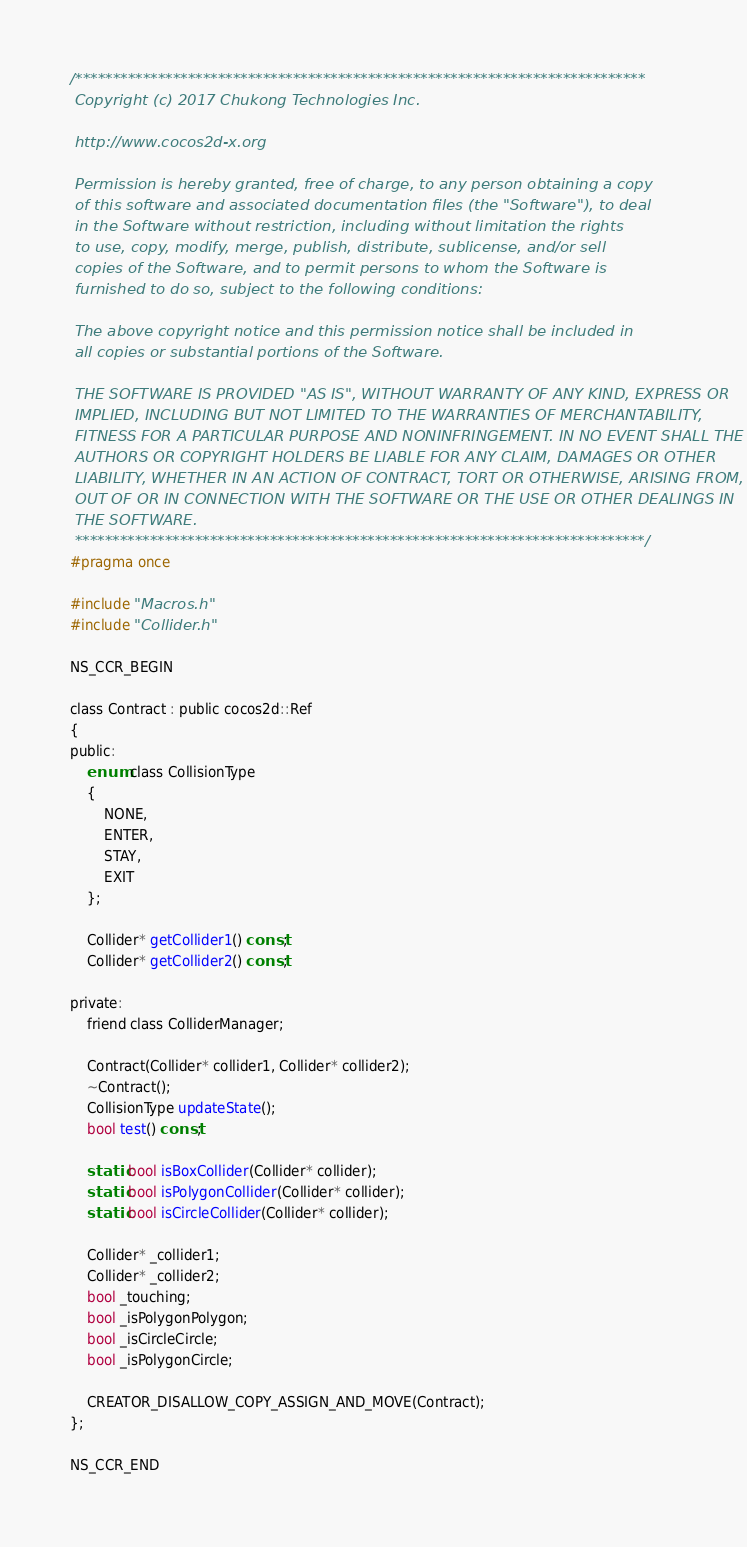<code> <loc_0><loc_0><loc_500><loc_500><_C_>/****************************************************************************
 Copyright (c) 2017 Chukong Technologies Inc.
 
 http://www.cocos2d-x.org
 
 Permission is hereby granted, free of charge, to any person obtaining a copy
 of this software and associated documentation files (the "Software"), to deal
 in the Software without restriction, including without limitation the rights
 to use, copy, modify, merge, publish, distribute, sublicense, and/or sell
 copies of the Software, and to permit persons to whom the Software is
 furnished to do so, subject to the following conditions:
 
 The above copyright notice and this permission notice shall be included in
 all copies or substantial portions of the Software.
 
 THE SOFTWARE IS PROVIDED "AS IS", WITHOUT WARRANTY OF ANY KIND, EXPRESS OR
 IMPLIED, INCLUDING BUT NOT LIMITED TO THE WARRANTIES OF MERCHANTABILITY,
 FITNESS FOR A PARTICULAR PURPOSE AND NONINFRINGEMENT. IN NO EVENT SHALL THE
 AUTHORS OR COPYRIGHT HOLDERS BE LIABLE FOR ANY CLAIM, DAMAGES OR OTHER
 LIABILITY, WHETHER IN AN ACTION OF CONTRACT, TORT OR OTHERWISE, ARISING FROM,
 OUT OF OR IN CONNECTION WITH THE SOFTWARE OR THE USE OR OTHER DEALINGS IN
 THE SOFTWARE.
 ****************************************************************************/
#pragma once

#include "Macros.h"
#include "Collider.h"

NS_CCR_BEGIN

class Contract : public cocos2d::Ref
{
public:
    enum class CollisionType
    {
        NONE,
        ENTER,
        STAY,
        EXIT
    };
    
    Collider* getCollider1() const;
    Collider* getCollider2() const;
    
private:
    friend class ColliderManager;
    
    Contract(Collider* collider1, Collider* collider2);
    ~Contract();
    CollisionType updateState();
    bool test() const;
    
    static bool isBoxCollider(Collider* collider);
    static bool isPolygonCollider(Collider* collider);
    static bool isCircleCollider(Collider* collider);
    
    Collider* _collider1;
    Collider* _collider2;
    bool _touching;
    bool _isPolygonPolygon;
    bool _isCircleCircle;
    bool _isPolygonCircle;
    
    CREATOR_DISALLOW_COPY_ASSIGN_AND_MOVE(Contract);
};

NS_CCR_END
</code> 